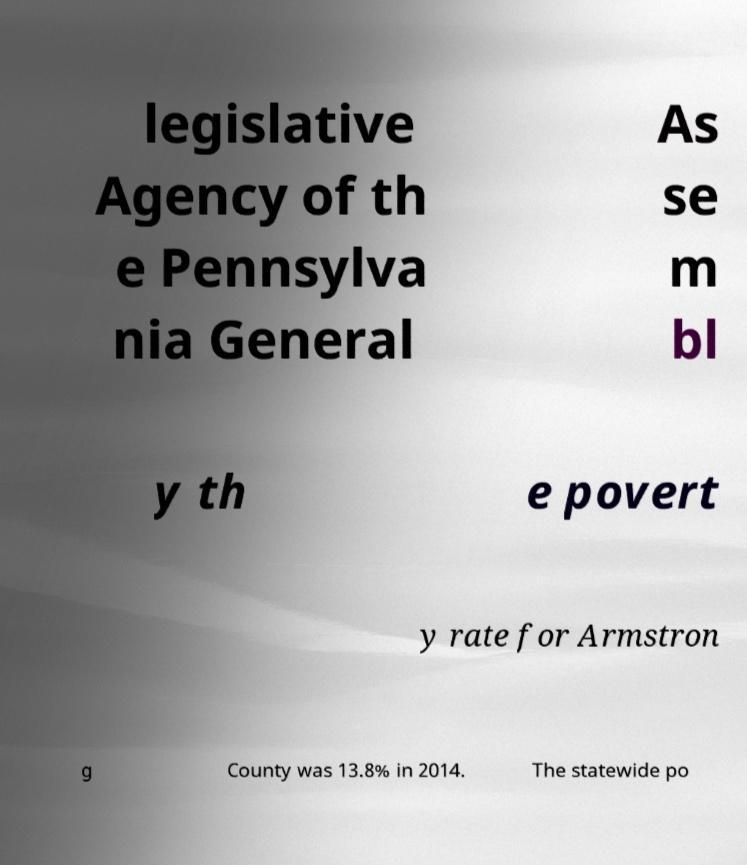Can you accurately transcribe the text from the provided image for me? legislative Agency of th e Pennsylva nia General As se m bl y th e povert y rate for Armstron g County was 13.8% in 2014. The statewide po 